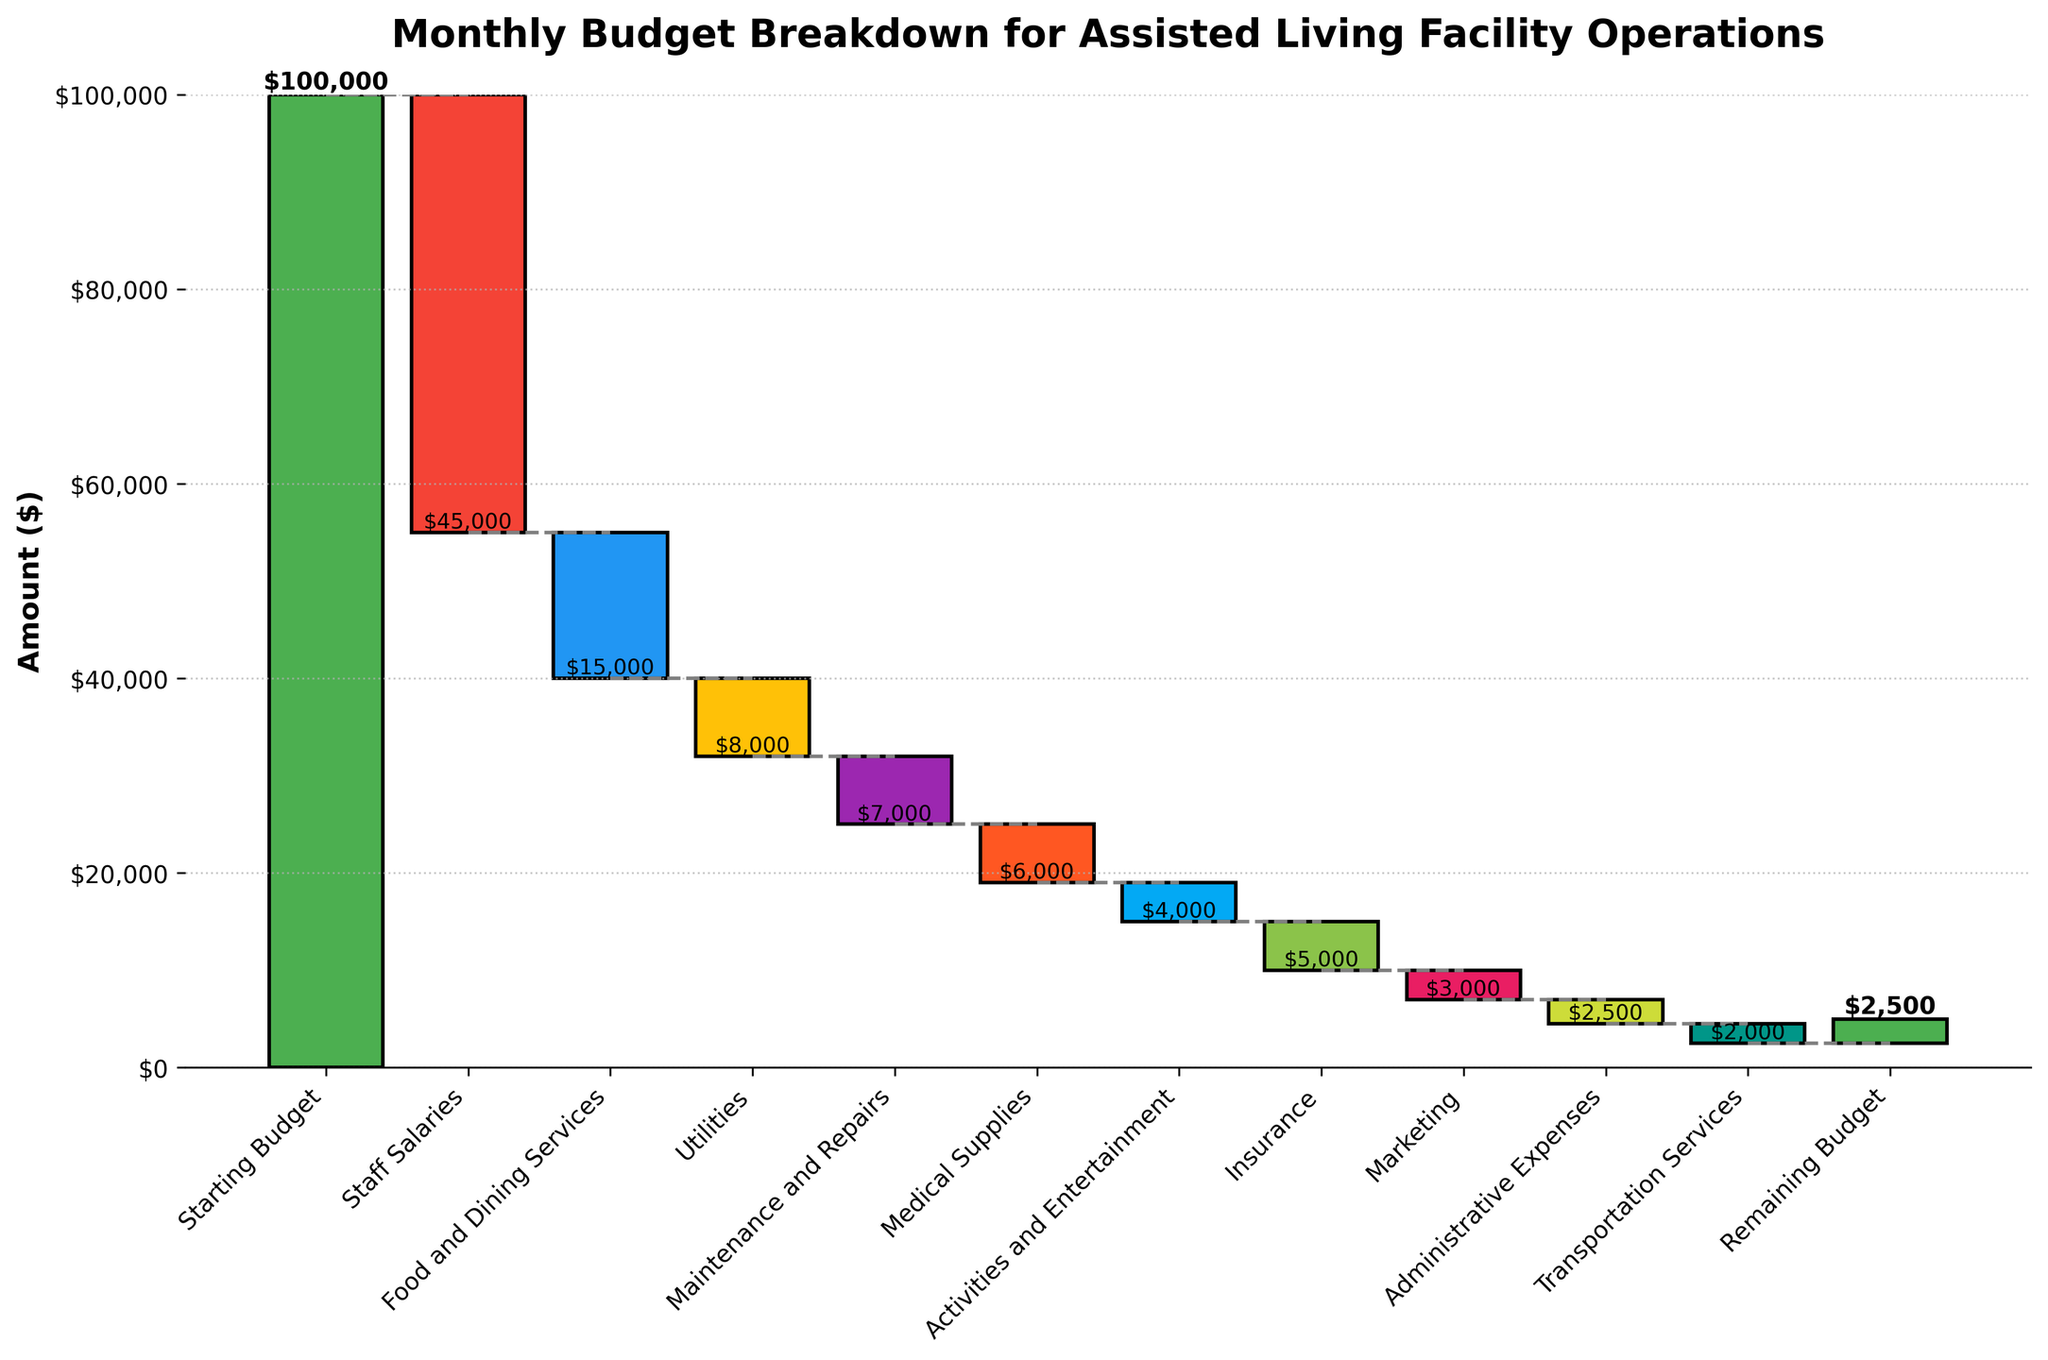What is the starting budget mentioned in the chart? According to the first bar in the chart, the starting budget is highlighted as the positive green bar, which clearly shows the value.
Answer: $100,000 How much is being spent on staff salaries? The bar labeled "Staff Salaries" shows a significant dip, indicating a negative value. The chart labels this amount clearly.
Answer: $45,000 What is the remaining budget after accounting for all expenditures? The last bar in the chart labeled "Remaining Budget" shows the final value after all deductions have been applied. The bar is green, showing a remaining positive value.
Answer: $2,500 Which category has the highest expenditure value? By comparing the lengths of all the negative bars, "Staff Salaries" stands out as the longest bar, indicating the highest expenditure.
Answer: Staff Salaries If you sum the expenses for "Food and Dining Services" and "Utilities", what is the total? "Food and Dining Services" has a value of $15,000, and "Utilities" has a value of $8,000. Summing these two gives: $15,000 + $8,000 = $23,000
Answer: $23,000 How does the cost of "Maintenance and Repairs" compare to "Medical Supplies"? According to the chart, "Maintenance and Repairs" costs $7,000, while "Medical Supplies" costs $6,000. Maintenance is higher by $1,000.
Answer: Maintenance and Repairs is higher by $1,000 Which two expenditure categories, when combined, equal $10,000? By examining the chart, "Activities and Entertainment" ($4,000) and "Administrative Expenses" ($2,500) together form $6,500, while "Utilities" ($8,000) combined with "Transportation Services" ($2,000) form $10,000.
Answer: Utilities and Transportation Services Is the cost of "Insurance" higher or lower than "Marketing"? Comparing the bars for "Insurance" and "Marketing", "Insurance" is shown to be $5,000 whereas "Marketing" is $3,000. Thus, insurance is higher.
Answer: Higher What percentage of the starting budget is spent on "Utilities"? The expenditure on "Utilities" is $8,000, and the starting budget is $100,000. The percentage is calculated as (8,000 / 100,000) * 100 = 8%.
Answer: 8% What is the total of all expenditures listed in the chart? Sum up all the negative values: $45,000 (Staff Salaries) + $15,000 (Food and Dining Services) + $8,000 (Utilities) + $7,000 (Maintenance and Repairs) + $6,000 (Medical Supplies) + $4,000 (Activities and Entertainment) + $5,000 (Insurance) + $3,000 (Marketing) + $2,500 (Administrative Expenses) + $2,000 (Transportation Services). Total: $97,500.
Answer: $97,500 